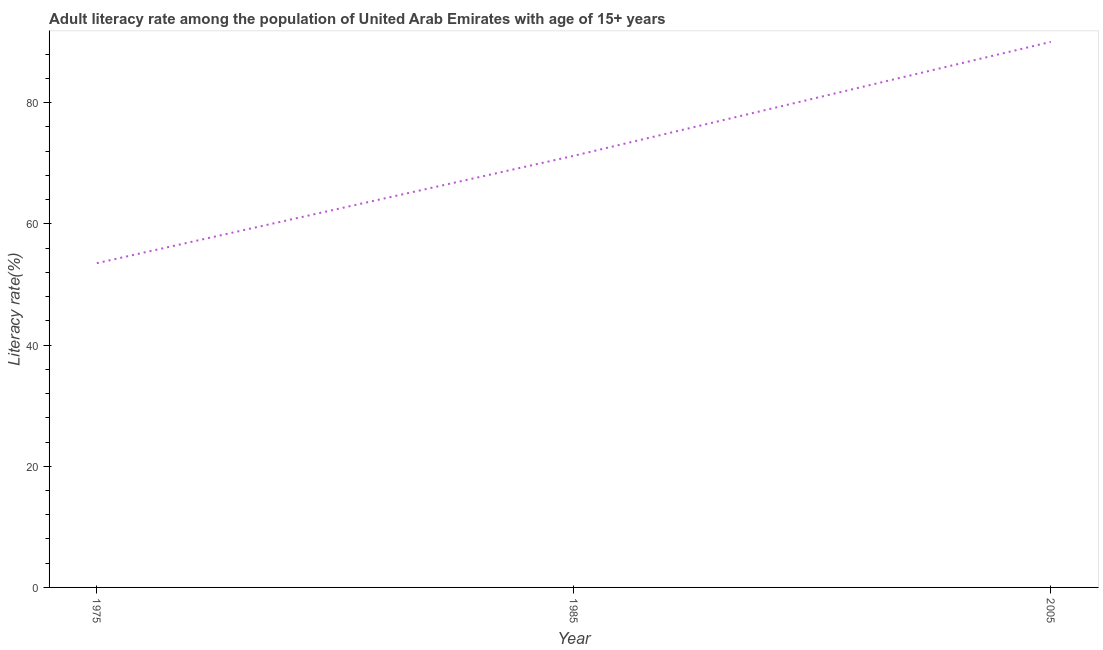What is the adult literacy rate in 1985?
Offer a terse response. 71.24. Across all years, what is the maximum adult literacy rate?
Give a very brief answer. 90.03. Across all years, what is the minimum adult literacy rate?
Make the answer very short. 53.51. In which year was the adult literacy rate maximum?
Offer a very short reply. 2005. In which year was the adult literacy rate minimum?
Provide a succinct answer. 1975. What is the sum of the adult literacy rate?
Your answer should be compact. 214.78. What is the difference between the adult literacy rate in 1975 and 1985?
Keep it short and to the point. -17.72. What is the average adult literacy rate per year?
Your answer should be compact. 71.59. What is the median adult literacy rate?
Make the answer very short. 71.24. In how many years, is the adult literacy rate greater than 36 %?
Make the answer very short. 3. What is the ratio of the adult literacy rate in 1975 to that in 2005?
Give a very brief answer. 0.59. Is the difference between the adult literacy rate in 1975 and 2005 greater than the difference between any two years?
Give a very brief answer. Yes. What is the difference between the highest and the second highest adult literacy rate?
Keep it short and to the point. 18.8. Is the sum of the adult literacy rate in 1985 and 2005 greater than the maximum adult literacy rate across all years?
Your answer should be very brief. Yes. What is the difference between the highest and the lowest adult literacy rate?
Offer a terse response. 36.52. How many years are there in the graph?
Provide a succinct answer. 3. Does the graph contain any zero values?
Keep it short and to the point. No. Does the graph contain grids?
Keep it short and to the point. No. What is the title of the graph?
Provide a short and direct response. Adult literacy rate among the population of United Arab Emirates with age of 15+ years. What is the label or title of the Y-axis?
Keep it short and to the point. Literacy rate(%). What is the Literacy rate(%) of 1975?
Offer a terse response. 53.51. What is the Literacy rate(%) of 1985?
Provide a short and direct response. 71.24. What is the Literacy rate(%) in 2005?
Your answer should be compact. 90.03. What is the difference between the Literacy rate(%) in 1975 and 1985?
Offer a terse response. -17.72. What is the difference between the Literacy rate(%) in 1975 and 2005?
Ensure brevity in your answer.  -36.52. What is the difference between the Literacy rate(%) in 1985 and 2005?
Ensure brevity in your answer.  -18.8. What is the ratio of the Literacy rate(%) in 1975 to that in 1985?
Offer a very short reply. 0.75. What is the ratio of the Literacy rate(%) in 1975 to that in 2005?
Offer a terse response. 0.59. What is the ratio of the Literacy rate(%) in 1985 to that in 2005?
Provide a succinct answer. 0.79. 